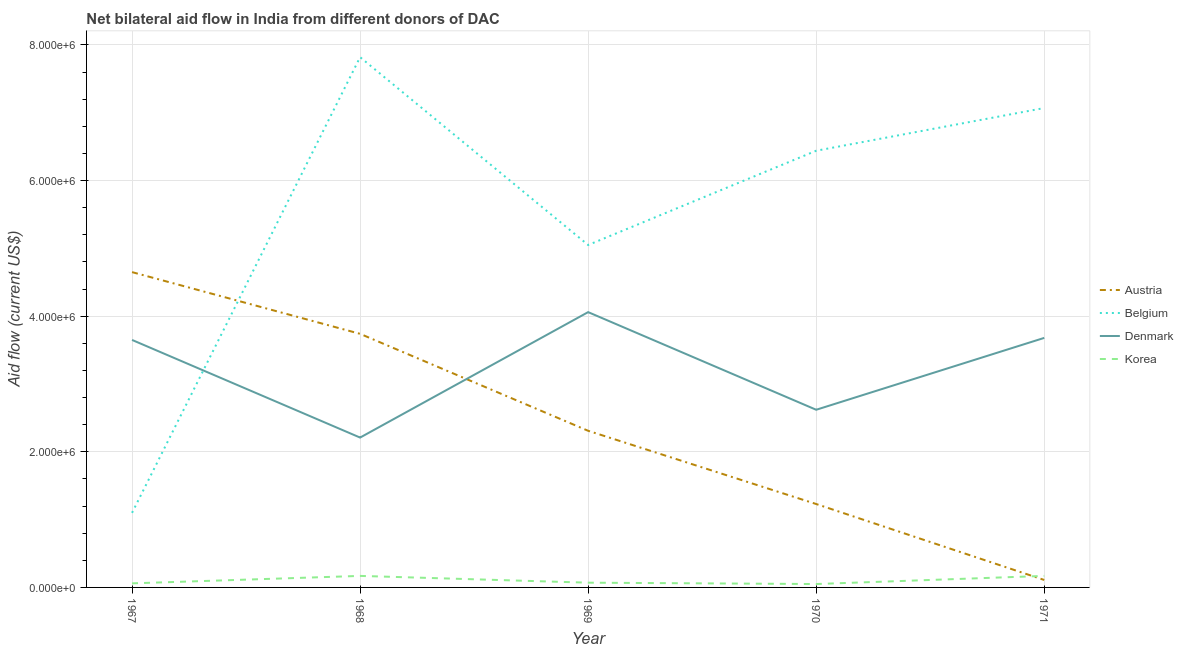How many different coloured lines are there?
Make the answer very short. 4. Is the number of lines equal to the number of legend labels?
Keep it short and to the point. Yes. What is the amount of aid given by belgium in 1969?
Offer a terse response. 5.05e+06. Across all years, what is the maximum amount of aid given by belgium?
Offer a very short reply. 7.82e+06. Across all years, what is the minimum amount of aid given by austria?
Provide a succinct answer. 1.10e+05. In which year was the amount of aid given by korea maximum?
Your answer should be compact. 1968. In which year was the amount of aid given by denmark minimum?
Your answer should be compact. 1968. What is the total amount of aid given by belgium in the graph?
Give a very brief answer. 2.75e+07. What is the difference between the amount of aid given by belgium in 1969 and that in 1971?
Make the answer very short. -2.02e+06. What is the difference between the amount of aid given by denmark in 1967 and the amount of aid given by belgium in 1970?
Provide a short and direct response. -2.79e+06. What is the average amount of aid given by korea per year?
Your response must be concise. 1.04e+05. In the year 1971, what is the difference between the amount of aid given by korea and amount of aid given by denmark?
Make the answer very short. -3.51e+06. What is the ratio of the amount of aid given by korea in 1969 to that in 1970?
Your response must be concise. 1.4. Is the amount of aid given by austria in 1967 less than that in 1971?
Offer a very short reply. No. What is the difference between the highest and the second highest amount of aid given by belgium?
Make the answer very short. 7.50e+05. What is the difference between the highest and the lowest amount of aid given by denmark?
Ensure brevity in your answer.  1.85e+06. In how many years, is the amount of aid given by korea greater than the average amount of aid given by korea taken over all years?
Keep it short and to the point. 2. Is it the case that in every year, the sum of the amount of aid given by belgium and amount of aid given by denmark is greater than the sum of amount of aid given by korea and amount of aid given by austria?
Provide a succinct answer. No. How many lines are there?
Give a very brief answer. 4. How many years are there in the graph?
Give a very brief answer. 5. Are the values on the major ticks of Y-axis written in scientific E-notation?
Your answer should be very brief. Yes. Does the graph contain grids?
Make the answer very short. Yes. How many legend labels are there?
Your response must be concise. 4. What is the title of the graph?
Your response must be concise. Net bilateral aid flow in India from different donors of DAC. What is the label or title of the X-axis?
Your response must be concise. Year. What is the label or title of the Y-axis?
Make the answer very short. Aid flow (current US$). What is the Aid flow (current US$) of Austria in 1967?
Your answer should be compact. 4.65e+06. What is the Aid flow (current US$) of Belgium in 1967?
Your answer should be very brief. 1.10e+06. What is the Aid flow (current US$) in Denmark in 1967?
Make the answer very short. 3.65e+06. What is the Aid flow (current US$) in Austria in 1968?
Give a very brief answer. 3.74e+06. What is the Aid flow (current US$) in Belgium in 1968?
Offer a terse response. 7.82e+06. What is the Aid flow (current US$) of Denmark in 1968?
Keep it short and to the point. 2.21e+06. What is the Aid flow (current US$) in Austria in 1969?
Your response must be concise. 2.31e+06. What is the Aid flow (current US$) in Belgium in 1969?
Make the answer very short. 5.05e+06. What is the Aid flow (current US$) of Denmark in 1969?
Ensure brevity in your answer.  4.06e+06. What is the Aid flow (current US$) in Korea in 1969?
Your answer should be compact. 7.00e+04. What is the Aid flow (current US$) of Austria in 1970?
Your answer should be compact. 1.23e+06. What is the Aid flow (current US$) in Belgium in 1970?
Your answer should be very brief. 6.44e+06. What is the Aid flow (current US$) of Denmark in 1970?
Offer a terse response. 2.62e+06. What is the Aid flow (current US$) in Belgium in 1971?
Offer a terse response. 7.07e+06. What is the Aid flow (current US$) in Denmark in 1971?
Ensure brevity in your answer.  3.68e+06. What is the Aid flow (current US$) in Korea in 1971?
Provide a short and direct response. 1.70e+05. Across all years, what is the maximum Aid flow (current US$) in Austria?
Make the answer very short. 4.65e+06. Across all years, what is the maximum Aid flow (current US$) of Belgium?
Give a very brief answer. 7.82e+06. Across all years, what is the maximum Aid flow (current US$) of Denmark?
Your response must be concise. 4.06e+06. Across all years, what is the maximum Aid flow (current US$) of Korea?
Ensure brevity in your answer.  1.70e+05. Across all years, what is the minimum Aid flow (current US$) in Austria?
Provide a succinct answer. 1.10e+05. Across all years, what is the minimum Aid flow (current US$) of Belgium?
Your answer should be compact. 1.10e+06. Across all years, what is the minimum Aid flow (current US$) of Denmark?
Offer a very short reply. 2.21e+06. What is the total Aid flow (current US$) in Austria in the graph?
Offer a terse response. 1.20e+07. What is the total Aid flow (current US$) in Belgium in the graph?
Your response must be concise. 2.75e+07. What is the total Aid flow (current US$) in Denmark in the graph?
Provide a short and direct response. 1.62e+07. What is the total Aid flow (current US$) in Korea in the graph?
Offer a very short reply. 5.20e+05. What is the difference between the Aid flow (current US$) of Austria in 1967 and that in 1968?
Make the answer very short. 9.10e+05. What is the difference between the Aid flow (current US$) in Belgium in 1967 and that in 1968?
Your answer should be compact. -6.72e+06. What is the difference between the Aid flow (current US$) of Denmark in 1967 and that in 1968?
Provide a short and direct response. 1.44e+06. What is the difference between the Aid flow (current US$) in Austria in 1967 and that in 1969?
Keep it short and to the point. 2.34e+06. What is the difference between the Aid flow (current US$) of Belgium in 1967 and that in 1969?
Your answer should be compact. -3.95e+06. What is the difference between the Aid flow (current US$) of Denmark in 1967 and that in 1969?
Provide a succinct answer. -4.10e+05. What is the difference between the Aid flow (current US$) of Austria in 1967 and that in 1970?
Your response must be concise. 3.42e+06. What is the difference between the Aid flow (current US$) in Belgium in 1967 and that in 1970?
Your response must be concise. -5.34e+06. What is the difference between the Aid flow (current US$) in Denmark in 1967 and that in 1970?
Give a very brief answer. 1.03e+06. What is the difference between the Aid flow (current US$) of Austria in 1967 and that in 1971?
Provide a succinct answer. 4.54e+06. What is the difference between the Aid flow (current US$) in Belgium in 1967 and that in 1971?
Offer a very short reply. -5.97e+06. What is the difference between the Aid flow (current US$) of Denmark in 1967 and that in 1971?
Ensure brevity in your answer.  -3.00e+04. What is the difference between the Aid flow (current US$) of Austria in 1968 and that in 1969?
Provide a succinct answer. 1.43e+06. What is the difference between the Aid flow (current US$) of Belgium in 1968 and that in 1969?
Provide a short and direct response. 2.77e+06. What is the difference between the Aid flow (current US$) in Denmark in 1968 and that in 1969?
Your answer should be very brief. -1.85e+06. What is the difference between the Aid flow (current US$) in Korea in 1968 and that in 1969?
Your answer should be very brief. 1.00e+05. What is the difference between the Aid flow (current US$) of Austria in 1968 and that in 1970?
Make the answer very short. 2.51e+06. What is the difference between the Aid flow (current US$) in Belgium in 1968 and that in 1970?
Provide a succinct answer. 1.38e+06. What is the difference between the Aid flow (current US$) of Denmark in 1968 and that in 1970?
Your answer should be very brief. -4.10e+05. What is the difference between the Aid flow (current US$) in Austria in 1968 and that in 1971?
Your response must be concise. 3.63e+06. What is the difference between the Aid flow (current US$) of Belgium in 1968 and that in 1971?
Make the answer very short. 7.50e+05. What is the difference between the Aid flow (current US$) in Denmark in 1968 and that in 1971?
Your response must be concise. -1.47e+06. What is the difference between the Aid flow (current US$) in Korea in 1968 and that in 1971?
Your answer should be very brief. 0. What is the difference between the Aid flow (current US$) of Austria in 1969 and that in 1970?
Keep it short and to the point. 1.08e+06. What is the difference between the Aid flow (current US$) of Belgium in 1969 and that in 1970?
Keep it short and to the point. -1.39e+06. What is the difference between the Aid flow (current US$) of Denmark in 1969 and that in 1970?
Provide a succinct answer. 1.44e+06. What is the difference between the Aid flow (current US$) in Austria in 1969 and that in 1971?
Keep it short and to the point. 2.20e+06. What is the difference between the Aid flow (current US$) in Belgium in 1969 and that in 1971?
Your answer should be very brief. -2.02e+06. What is the difference between the Aid flow (current US$) in Denmark in 1969 and that in 1971?
Ensure brevity in your answer.  3.80e+05. What is the difference between the Aid flow (current US$) in Korea in 1969 and that in 1971?
Provide a short and direct response. -1.00e+05. What is the difference between the Aid flow (current US$) in Austria in 1970 and that in 1971?
Your answer should be very brief. 1.12e+06. What is the difference between the Aid flow (current US$) of Belgium in 1970 and that in 1971?
Your response must be concise. -6.30e+05. What is the difference between the Aid flow (current US$) in Denmark in 1970 and that in 1971?
Keep it short and to the point. -1.06e+06. What is the difference between the Aid flow (current US$) in Korea in 1970 and that in 1971?
Offer a very short reply. -1.20e+05. What is the difference between the Aid flow (current US$) of Austria in 1967 and the Aid flow (current US$) of Belgium in 1968?
Offer a very short reply. -3.17e+06. What is the difference between the Aid flow (current US$) in Austria in 1967 and the Aid flow (current US$) in Denmark in 1968?
Make the answer very short. 2.44e+06. What is the difference between the Aid flow (current US$) of Austria in 1967 and the Aid flow (current US$) of Korea in 1968?
Make the answer very short. 4.48e+06. What is the difference between the Aid flow (current US$) of Belgium in 1967 and the Aid flow (current US$) of Denmark in 1968?
Your response must be concise. -1.11e+06. What is the difference between the Aid flow (current US$) of Belgium in 1967 and the Aid flow (current US$) of Korea in 1968?
Provide a short and direct response. 9.30e+05. What is the difference between the Aid flow (current US$) in Denmark in 1967 and the Aid flow (current US$) in Korea in 1968?
Offer a terse response. 3.48e+06. What is the difference between the Aid flow (current US$) in Austria in 1967 and the Aid flow (current US$) in Belgium in 1969?
Your answer should be very brief. -4.00e+05. What is the difference between the Aid flow (current US$) of Austria in 1967 and the Aid flow (current US$) of Denmark in 1969?
Give a very brief answer. 5.90e+05. What is the difference between the Aid flow (current US$) of Austria in 1967 and the Aid flow (current US$) of Korea in 1969?
Your response must be concise. 4.58e+06. What is the difference between the Aid flow (current US$) in Belgium in 1967 and the Aid flow (current US$) in Denmark in 1969?
Ensure brevity in your answer.  -2.96e+06. What is the difference between the Aid flow (current US$) of Belgium in 1967 and the Aid flow (current US$) of Korea in 1969?
Make the answer very short. 1.03e+06. What is the difference between the Aid flow (current US$) of Denmark in 1967 and the Aid flow (current US$) of Korea in 1969?
Offer a terse response. 3.58e+06. What is the difference between the Aid flow (current US$) of Austria in 1967 and the Aid flow (current US$) of Belgium in 1970?
Provide a succinct answer. -1.79e+06. What is the difference between the Aid flow (current US$) in Austria in 1967 and the Aid flow (current US$) in Denmark in 1970?
Make the answer very short. 2.03e+06. What is the difference between the Aid flow (current US$) of Austria in 1967 and the Aid flow (current US$) of Korea in 1970?
Your answer should be very brief. 4.60e+06. What is the difference between the Aid flow (current US$) of Belgium in 1967 and the Aid flow (current US$) of Denmark in 1970?
Your answer should be very brief. -1.52e+06. What is the difference between the Aid flow (current US$) of Belgium in 1967 and the Aid flow (current US$) of Korea in 1970?
Keep it short and to the point. 1.05e+06. What is the difference between the Aid flow (current US$) of Denmark in 1967 and the Aid flow (current US$) of Korea in 1970?
Your response must be concise. 3.60e+06. What is the difference between the Aid flow (current US$) in Austria in 1967 and the Aid flow (current US$) in Belgium in 1971?
Offer a very short reply. -2.42e+06. What is the difference between the Aid flow (current US$) in Austria in 1967 and the Aid flow (current US$) in Denmark in 1971?
Give a very brief answer. 9.70e+05. What is the difference between the Aid flow (current US$) in Austria in 1967 and the Aid flow (current US$) in Korea in 1971?
Your answer should be compact. 4.48e+06. What is the difference between the Aid flow (current US$) of Belgium in 1967 and the Aid flow (current US$) of Denmark in 1971?
Provide a succinct answer. -2.58e+06. What is the difference between the Aid flow (current US$) in Belgium in 1967 and the Aid flow (current US$) in Korea in 1971?
Provide a succinct answer. 9.30e+05. What is the difference between the Aid flow (current US$) in Denmark in 1967 and the Aid flow (current US$) in Korea in 1971?
Offer a terse response. 3.48e+06. What is the difference between the Aid flow (current US$) in Austria in 1968 and the Aid flow (current US$) in Belgium in 1969?
Ensure brevity in your answer.  -1.31e+06. What is the difference between the Aid flow (current US$) in Austria in 1968 and the Aid flow (current US$) in Denmark in 1969?
Ensure brevity in your answer.  -3.20e+05. What is the difference between the Aid flow (current US$) in Austria in 1968 and the Aid flow (current US$) in Korea in 1969?
Ensure brevity in your answer.  3.67e+06. What is the difference between the Aid flow (current US$) in Belgium in 1968 and the Aid flow (current US$) in Denmark in 1969?
Your answer should be very brief. 3.76e+06. What is the difference between the Aid flow (current US$) in Belgium in 1968 and the Aid flow (current US$) in Korea in 1969?
Your answer should be compact. 7.75e+06. What is the difference between the Aid flow (current US$) of Denmark in 1968 and the Aid flow (current US$) of Korea in 1969?
Ensure brevity in your answer.  2.14e+06. What is the difference between the Aid flow (current US$) in Austria in 1968 and the Aid flow (current US$) in Belgium in 1970?
Give a very brief answer. -2.70e+06. What is the difference between the Aid flow (current US$) in Austria in 1968 and the Aid flow (current US$) in Denmark in 1970?
Offer a very short reply. 1.12e+06. What is the difference between the Aid flow (current US$) in Austria in 1968 and the Aid flow (current US$) in Korea in 1970?
Ensure brevity in your answer.  3.69e+06. What is the difference between the Aid flow (current US$) in Belgium in 1968 and the Aid flow (current US$) in Denmark in 1970?
Give a very brief answer. 5.20e+06. What is the difference between the Aid flow (current US$) in Belgium in 1968 and the Aid flow (current US$) in Korea in 1970?
Your answer should be very brief. 7.77e+06. What is the difference between the Aid flow (current US$) in Denmark in 1968 and the Aid flow (current US$) in Korea in 1970?
Make the answer very short. 2.16e+06. What is the difference between the Aid flow (current US$) of Austria in 1968 and the Aid flow (current US$) of Belgium in 1971?
Ensure brevity in your answer.  -3.33e+06. What is the difference between the Aid flow (current US$) in Austria in 1968 and the Aid flow (current US$) in Denmark in 1971?
Your response must be concise. 6.00e+04. What is the difference between the Aid flow (current US$) in Austria in 1968 and the Aid flow (current US$) in Korea in 1971?
Offer a very short reply. 3.57e+06. What is the difference between the Aid flow (current US$) in Belgium in 1968 and the Aid flow (current US$) in Denmark in 1971?
Offer a very short reply. 4.14e+06. What is the difference between the Aid flow (current US$) of Belgium in 1968 and the Aid flow (current US$) of Korea in 1971?
Ensure brevity in your answer.  7.65e+06. What is the difference between the Aid flow (current US$) in Denmark in 1968 and the Aid flow (current US$) in Korea in 1971?
Keep it short and to the point. 2.04e+06. What is the difference between the Aid flow (current US$) in Austria in 1969 and the Aid flow (current US$) in Belgium in 1970?
Provide a succinct answer. -4.13e+06. What is the difference between the Aid flow (current US$) in Austria in 1969 and the Aid flow (current US$) in Denmark in 1970?
Your response must be concise. -3.10e+05. What is the difference between the Aid flow (current US$) in Austria in 1969 and the Aid flow (current US$) in Korea in 1970?
Make the answer very short. 2.26e+06. What is the difference between the Aid flow (current US$) of Belgium in 1969 and the Aid flow (current US$) of Denmark in 1970?
Give a very brief answer. 2.43e+06. What is the difference between the Aid flow (current US$) of Denmark in 1969 and the Aid flow (current US$) of Korea in 1970?
Keep it short and to the point. 4.01e+06. What is the difference between the Aid flow (current US$) in Austria in 1969 and the Aid flow (current US$) in Belgium in 1971?
Your answer should be compact. -4.76e+06. What is the difference between the Aid flow (current US$) in Austria in 1969 and the Aid flow (current US$) in Denmark in 1971?
Your answer should be compact. -1.37e+06. What is the difference between the Aid flow (current US$) in Austria in 1969 and the Aid flow (current US$) in Korea in 1971?
Your answer should be compact. 2.14e+06. What is the difference between the Aid flow (current US$) in Belgium in 1969 and the Aid flow (current US$) in Denmark in 1971?
Make the answer very short. 1.37e+06. What is the difference between the Aid flow (current US$) of Belgium in 1969 and the Aid flow (current US$) of Korea in 1971?
Provide a short and direct response. 4.88e+06. What is the difference between the Aid flow (current US$) in Denmark in 1969 and the Aid flow (current US$) in Korea in 1971?
Provide a short and direct response. 3.89e+06. What is the difference between the Aid flow (current US$) of Austria in 1970 and the Aid flow (current US$) of Belgium in 1971?
Your response must be concise. -5.84e+06. What is the difference between the Aid flow (current US$) of Austria in 1970 and the Aid flow (current US$) of Denmark in 1971?
Your answer should be very brief. -2.45e+06. What is the difference between the Aid flow (current US$) of Austria in 1970 and the Aid flow (current US$) of Korea in 1971?
Offer a very short reply. 1.06e+06. What is the difference between the Aid flow (current US$) in Belgium in 1970 and the Aid flow (current US$) in Denmark in 1971?
Your response must be concise. 2.76e+06. What is the difference between the Aid flow (current US$) of Belgium in 1970 and the Aid flow (current US$) of Korea in 1971?
Your response must be concise. 6.27e+06. What is the difference between the Aid flow (current US$) of Denmark in 1970 and the Aid flow (current US$) of Korea in 1971?
Ensure brevity in your answer.  2.45e+06. What is the average Aid flow (current US$) of Austria per year?
Provide a short and direct response. 2.41e+06. What is the average Aid flow (current US$) of Belgium per year?
Keep it short and to the point. 5.50e+06. What is the average Aid flow (current US$) of Denmark per year?
Make the answer very short. 3.24e+06. What is the average Aid flow (current US$) in Korea per year?
Offer a very short reply. 1.04e+05. In the year 1967, what is the difference between the Aid flow (current US$) in Austria and Aid flow (current US$) in Belgium?
Keep it short and to the point. 3.55e+06. In the year 1967, what is the difference between the Aid flow (current US$) of Austria and Aid flow (current US$) of Korea?
Offer a terse response. 4.59e+06. In the year 1967, what is the difference between the Aid flow (current US$) in Belgium and Aid flow (current US$) in Denmark?
Offer a terse response. -2.55e+06. In the year 1967, what is the difference between the Aid flow (current US$) of Belgium and Aid flow (current US$) of Korea?
Your answer should be compact. 1.04e+06. In the year 1967, what is the difference between the Aid flow (current US$) in Denmark and Aid flow (current US$) in Korea?
Ensure brevity in your answer.  3.59e+06. In the year 1968, what is the difference between the Aid flow (current US$) in Austria and Aid flow (current US$) in Belgium?
Ensure brevity in your answer.  -4.08e+06. In the year 1968, what is the difference between the Aid flow (current US$) of Austria and Aid flow (current US$) of Denmark?
Your answer should be compact. 1.53e+06. In the year 1968, what is the difference between the Aid flow (current US$) of Austria and Aid flow (current US$) of Korea?
Offer a very short reply. 3.57e+06. In the year 1968, what is the difference between the Aid flow (current US$) in Belgium and Aid flow (current US$) in Denmark?
Your answer should be very brief. 5.61e+06. In the year 1968, what is the difference between the Aid flow (current US$) in Belgium and Aid flow (current US$) in Korea?
Provide a succinct answer. 7.65e+06. In the year 1968, what is the difference between the Aid flow (current US$) of Denmark and Aid flow (current US$) of Korea?
Provide a succinct answer. 2.04e+06. In the year 1969, what is the difference between the Aid flow (current US$) in Austria and Aid flow (current US$) in Belgium?
Your response must be concise. -2.74e+06. In the year 1969, what is the difference between the Aid flow (current US$) in Austria and Aid flow (current US$) in Denmark?
Provide a succinct answer. -1.75e+06. In the year 1969, what is the difference between the Aid flow (current US$) of Austria and Aid flow (current US$) of Korea?
Your answer should be very brief. 2.24e+06. In the year 1969, what is the difference between the Aid flow (current US$) of Belgium and Aid flow (current US$) of Denmark?
Offer a terse response. 9.90e+05. In the year 1969, what is the difference between the Aid flow (current US$) in Belgium and Aid flow (current US$) in Korea?
Make the answer very short. 4.98e+06. In the year 1969, what is the difference between the Aid flow (current US$) in Denmark and Aid flow (current US$) in Korea?
Your answer should be compact. 3.99e+06. In the year 1970, what is the difference between the Aid flow (current US$) of Austria and Aid flow (current US$) of Belgium?
Ensure brevity in your answer.  -5.21e+06. In the year 1970, what is the difference between the Aid flow (current US$) of Austria and Aid flow (current US$) of Denmark?
Your response must be concise. -1.39e+06. In the year 1970, what is the difference between the Aid flow (current US$) of Austria and Aid flow (current US$) of Korea?
Your answer should be compact. 1.18e+06. In the year 1970, what is the difference between the Aid flow (current US$) in Belgium and Aid flow (current US$) in Denmark?
Your response must be concise. 3.82e+06. In the year 1970, what is the difference between the Aid flow (current US$) of Belgium and Aid flow (current US$) of Korea?
Provide a short and direct response. 6.39e+06. In the year 1970, what is the difference between the Aid flow (current US$) of Denmark and Aid flow (current US$) of Korea?
Your answer should be compact. 2.57e+06. In the year 1971, what is the difference between the Aid flow (current US$) in Austria and Aid flow (current US$) in Belgium?
Provide a succinct answer. -6.96e+06. In the year 1971, what is the difference between the Aid flow (current US$) in Austria and Aid flow (current US$) in Denmark?
Ensure brevity in your answer.  -3.57e+06. In the year 1971, what is the difference between the Aid flow (current US$) of Austria and Aid flow (current US$) of Korea?
Your answer should be compact. -6.00e+04. In the year 1971, what is the difference between the Aid flow (current US$) of Belgium and Aid flow (current US$) of Denmark?
Give a very brief answer. 3.39e+06. In the year 1971, what is the difference between the Aid flow (current US$) of Belgium and Aid flow (current US$) of Korea?
Your response must be concise. 6.90e+06. In the year 1971, what is the difference between the Aid flow (current US$) of Denmark and Aid flow (current US$) of Korea?
Your answer should be compact. 3.51e+06. What is the ratio of the Aid flow (current US$) of Austria in 1967 to that in 1968?
Provide a short and direct response. 1.24. What is the ratio of the Aid flow (current US$) in Belgium in 1967 to that in 1968?
Make the answer very short. 0.14. What is the ratio of the Aid flow (current US$) of Denmark in 1967 to that in 1968?
Offer a terse response. 1.65. What is the ratio of the Aid flow (current US$) in Korea in 1967 to that in 1968?
Give a very brief answer. 0.35. What is the ratio of the Aid flow (current US$) of Austria in 1967 to that in 1969?
Provide a succinct answer. 2.01. What is the ratio of the Aid flow (current US$) in Belgium in 1967 to that in 1969?
Give a very brief answer. 0.22. What is the ratio of the Aid flow (current US$) of Denmark in 1967 to that in 1969?
Keep it short and to the point. 0.9. What is the ratio of the Aid flow (current US$) of Austria in 1967 to that in 1970?
Your response must be concise. 3.78. What is the ratio of the Aid flow (current US$) in Belgium in 1967 to that in 1970?
Offer a very short reply. 0.17. What is the ratio of the Aid flow (current US$) in Denmark in 1967 to that in 1970?
Keep it short and to the point. 1.39. What is the ratio of the Aid flow (current US$) in Austria in 1967 to that in 1971?
Offer a terse response. 42.27. What is the ratio of the Aid flow (current US$) in Belgium in 1967 to that in 1971?
Provide a succinct answer. 0.16. What is the ratio of the Aid flow (current US$) of Korea in 1967 to that in 1971?
Provide a succinct answer. 0.35. What is the ratio of the Aid flow (current US$) in Austria in 1968 to that in 1969?
Provide a short and direct response. 1.62. What is the ratio of the Aid flow (current US$) in Belgium in 1968 to that in 1969?
Your answer should be very brief. 1.55. What is the ratio of the Aid flow (current US$) of Denmark in 1968 to that in 1969?
Offer a terse response. 0.54. What is the ratio of the Aid flow (current US$) of Korea in 1968 to that in 1969?
Give a very brief answer. 2.43. What is the ratio of the Aid flow (current US$) of Austria in 1968 to that in 1970?
Ensure brevity in your answer.  3.04. What is the ratio of the Aid flow (current US$) of Belgium in 1968 to that in 1970?
Ensure brevity in your answer.  1.21. What is the ratio of the Aid flow (current US$) of Denmark in 1968 to that in 1970?
Provide a succinct answer. 0.84. What is the ratio of the Aid flow (current US$) in Austria in 1968 to that in 1971?
Provide a short and direct response. 34. What is the ratio of the Aid flow (current US$) of Belgium in 1968 to that in 1971?
Offer a very short reply. 1.11. What is the ratio of the Aid flow (current US$) in Denmark in 1968 to that in 1971?
Give a very brief answer. 0.6. What is the ratio of the Aid flow (current US$) in Korea in 1968 to that in 1971?
Provide a succinct answer. 1. What is the ratio of the Aid flow (current US$) in Austria in 1969 to that in 1970?
Your answer should be very brief. 1.88. What is the ratio of the Aid flow (current US$) of Belgium in 1969 to that in 1970?
Your answer should be very brief. 0.78. What is the ratio of the Aid flow (current US$) in Denmark in 1969 to that in 1970?
Keep it short and to the point. 1.55. What is the ratio of the Aid flow (current US$) of Korea in 1969 to that in 1970?
Ensure brevity in your answer.  1.4. What is the ratio of the Aid flow (current US$) in Austria in 1969 to that in 1971?
Offer a very short reply. 21. What is the ratio of the Aid flow (current US$) in Denmark in 1969 to that in 1971?
Give a very brief answer. 1.1. What is the ratio of the Aid flow (current US$) in Korea in 1969 to that in 1971?
Offer a terse response. 0.41. What is the ratio of the Aid flow (current US$) of Austria in 1970 to that in 1971?
Your answer should be very brief. 11.18. What is the ratio of the Aid flow (current US$) in Belgium in 1970 to that in 1971?
Make the answer very short. 0.91. What is the ratio of the Aid flow (current US$) in Denmark in 1970 to that in 1971?
Make the answer very short. 0.71. What is the ratio of the Aid flow (current US$) in Korea in 1970 to that in 1971?
Offer a terse response. 0.29. What is the difference between the highest and the second highest Aid flow (current US$) in Austria?
Your response must be concise. 9.10e+05. What is the difference between the highest and the second highest Aid flow (current US$) of Belgium?
Provide a succinct answer. 7.50e+05. What is the difference between the highest and the second highest Aid flow (current US$) of Korea?
Provide a short and direct response. 0. What is the difference between the highest and the lowest Aid flow (current US$) in Austria?
Keep it short and to the point. 4.54e+06. What is the difference between the highest and the lowest Aid flow (current US$) in Belgium?
Provide a short and direct response. 6.72e+06. What is the difference between the highest and the lowest Aid flow (current US$) of Denmark?
Your answer should be compact. 1.85e+06. 